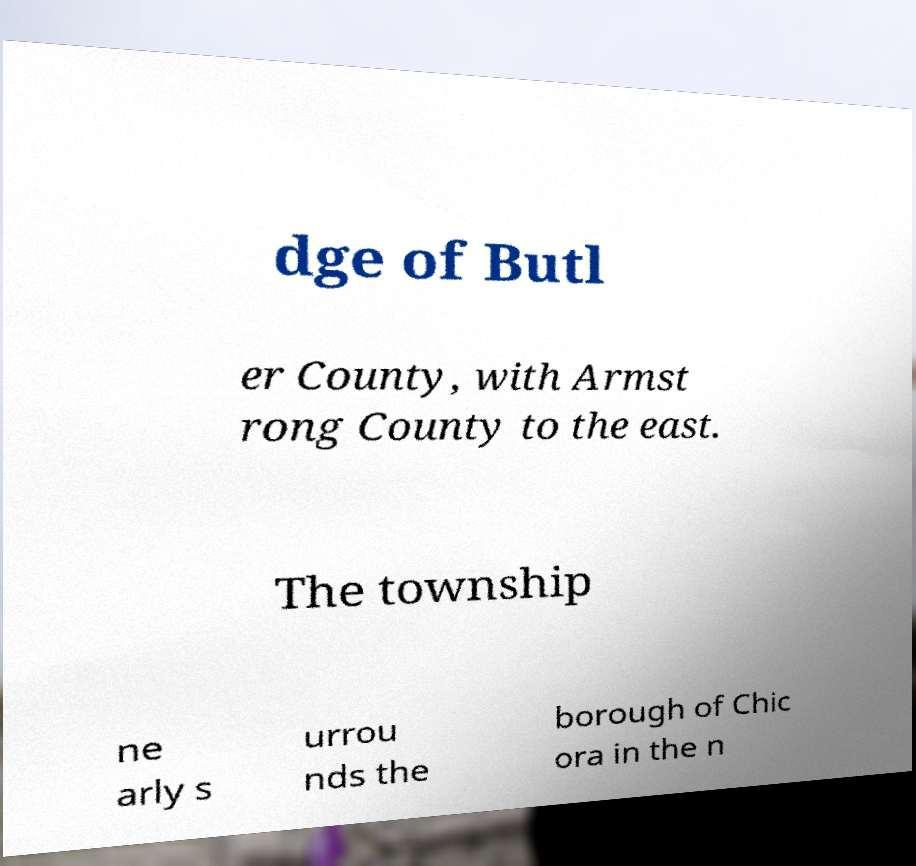For documentation purposes, I need the text within this image transcribed. Could you provide that? dge of Butl er County, with Armst rong County to the east. The township ne arly s urrou nds the borough of Chic ora in the n 